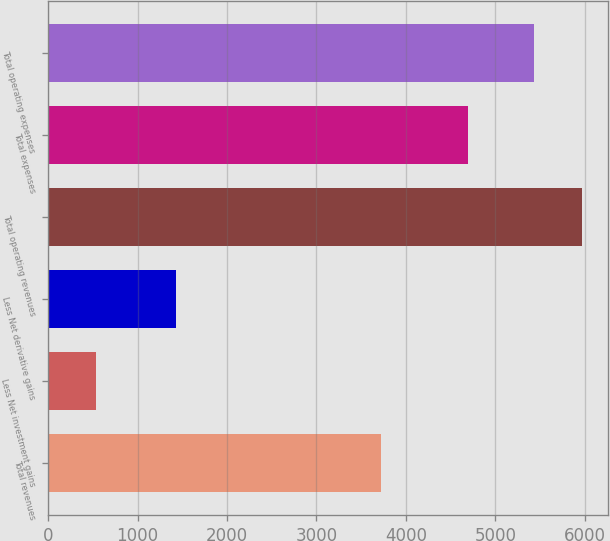Convert chart. <chart><loc_0><loc_0><loc_500><loc_500><bar_chart><fcel>Total revenues<fcel>Less Net investment gains<fcel>Less Net derivative gains<fcel>Total operating revenues<fcel>Total expenses<fcel>Total operating expenses<nl><fcel>3725<fcel>533<fcel>1426<fcel>5965<fcel>4690<fcel>5428<nl></chart> 